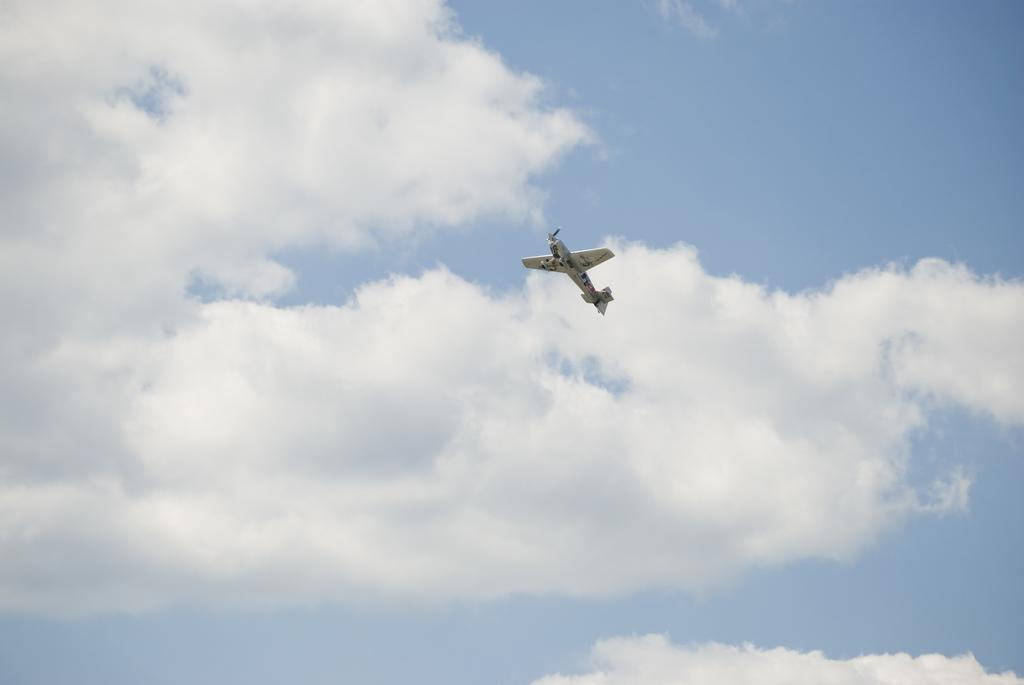What type of vehicle is in the picture? There is a small aircraft in the picture. What color is the aircraft? The aircraft is brown in color. What is the aircraft doing in the picture? The aircraft is flying in the sky. How would you describe the sky in the picture? The sky is blue with white clouds. What type of industry is visible in the picture? There is no industry visible in the picture; it features a small brown aircraft flying in the blue sky with white clouds. How does the stomach of the aircraft appear in the picture? Aircraft do not have stomachs, as they are machines and not living beings. 